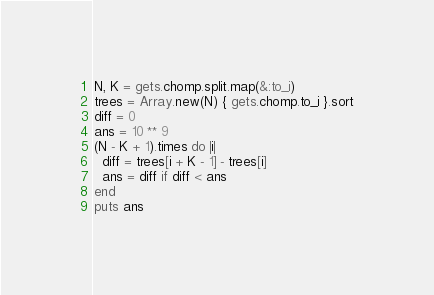<code> <loc_0><loc_0><loc_500><loc_500><_Ruby_>N, K = gets.chomp.split.map(&:to_i)
trees = Array.new(N) { gets.chomp.to_i }.sort
diff = 0
ans = 10 ** 9
(N - K + 1).times do |i|
  diff = trees[i + K - 1] - trees[i]
  ans = diff if diff < ans
end
puts ans
</code> 